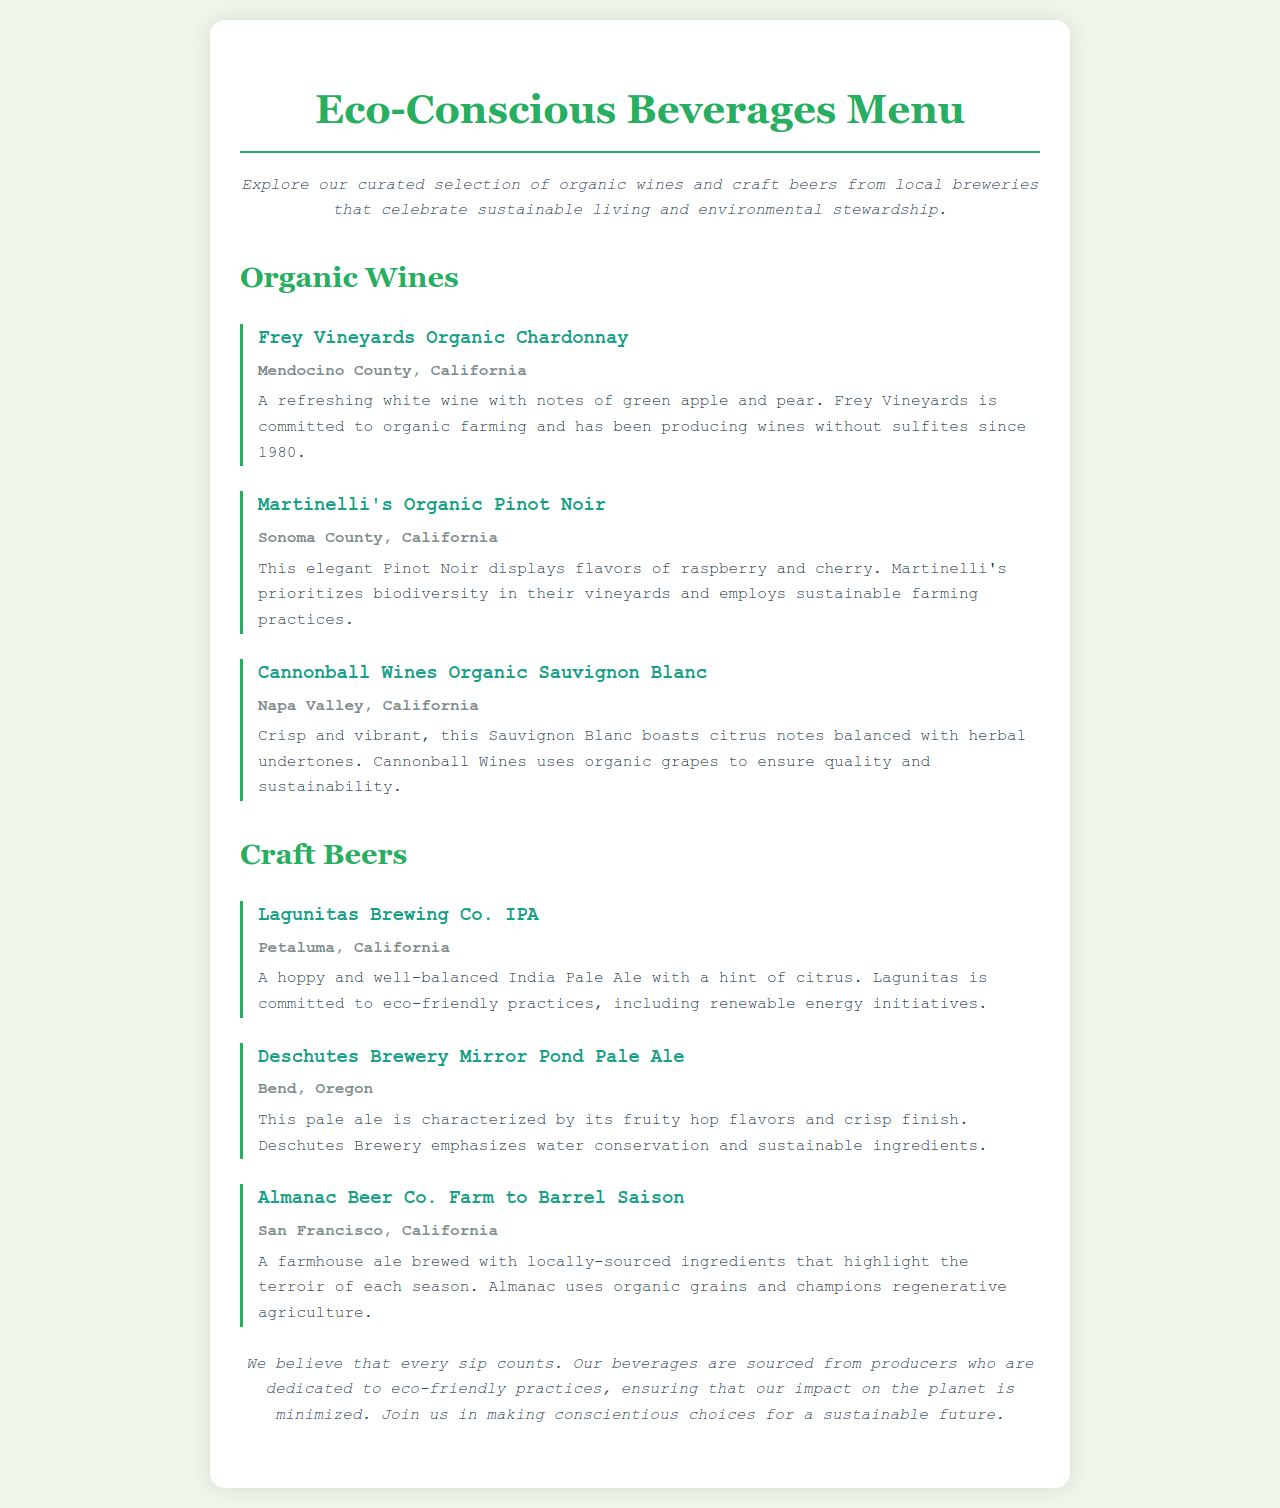What is the title of the menu? The title of the menu is prominently displayed at the top of the document.
Answer: Eco-Conscious Beverages Menu Where is Frey Vineyards Organic Chardonnay from? The document specifies the origin of this wine in the region section.
Answer: Mendocino County, California What sustainable practice does Martinelli's prioritize? This practice is mentioned in the description of Martinelli's wine.
Answer: Biodiversity What flavor notes are in Cannonball Wines Organic Sauvignon Blanc? The flavor notes are provided in the description of the wine.
Answer: Citrus notes balanced with herbal undertones Which brewery produces the Farm to Barrel Saison? The brewery name is indicated in the beverage section.
Answer: Almanac Beer Co How is the IPA described in terms of balance? The description of the IPA includes its taste profile.
Answer: Well-balanced What commitment do the beverage producers share? A specific commitment mentioned in the document highlights the overall philosophy of the beverage selection.
Answer: Eco-friendly practices What type of beer is produced by Deschutes Brewery? The type of beer is identified in the heading of the respective beverage section.
Answer: Pale Ale 